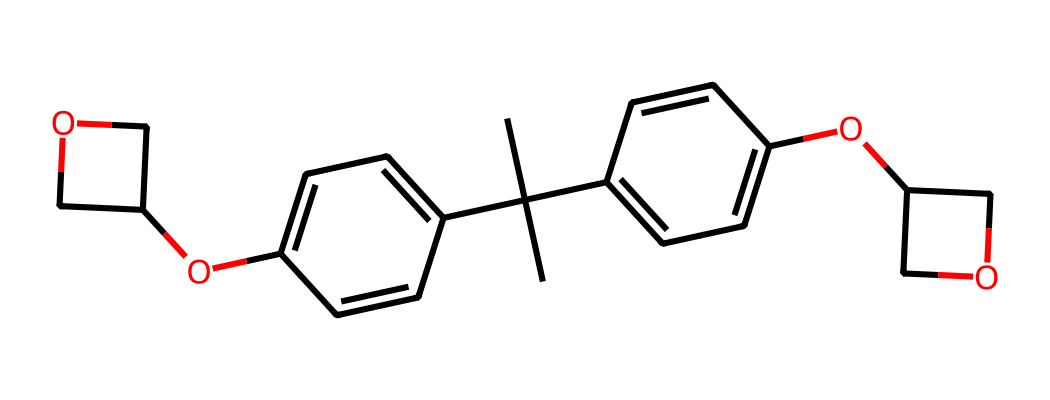What is the backbone structure of SU-8? The backbone structure of SU-8 consists of a central epoxy group, and it shows a polymeric nature due to the multiple aromatic rings branching off the central structure.
Answer: epoxy How many aromatic rings are present in SU-8? By inspecting the chemical structure, there are three distinct aromatic rings attached to the central structure, contributing to its chemical properties.
Answer: three What functional groups are identified in this chemical? By analyzing the structure, the main functional groups appear to be methoxy groups (-OCH3) attached to the aromatic rings, which influence the solubility and reactivity of SU-8.
Answer: methoxy What is the significance of the epoxy groups in SU-8? The presence of the epoxy groups in SU-8 is crucial as they allow for cross-linking during the lithography process, which makes the photoresist harden upon exposure to UV light.
Answer: cross-linking Is this compound a positive or negative photoresist? The structural characteristics and the presence of the epoxy groups indicate that SU-8 is an epoxy-based negative photoresist.
Answer: negative 